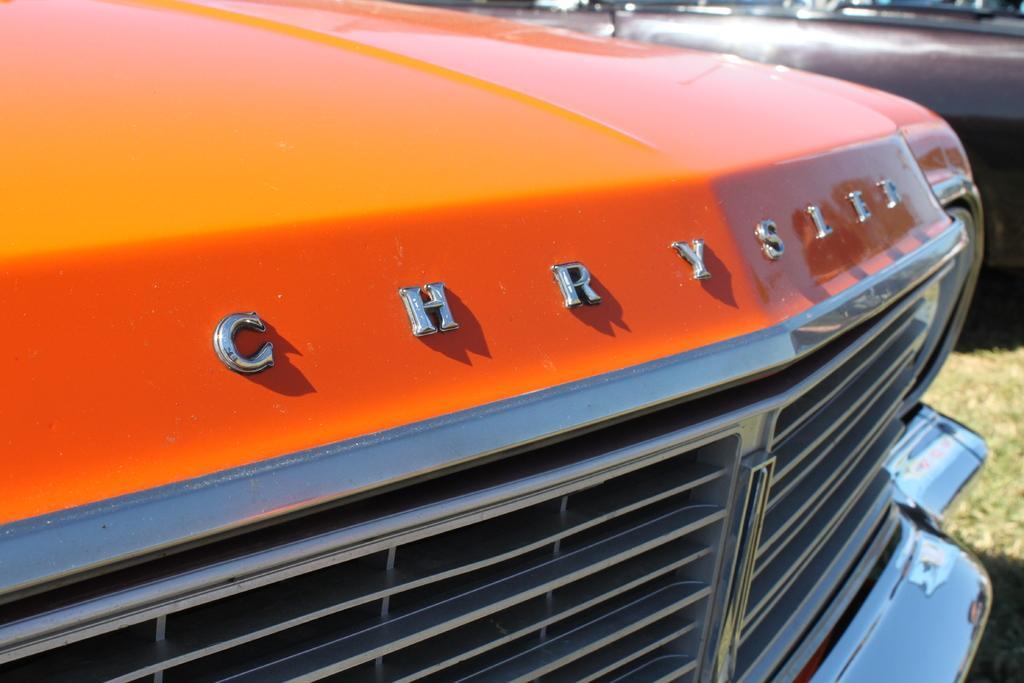In one or two sentences, can you explain what this image depicts? In this image in front there are cars. At the bottom of the image there is grass on the surface. 